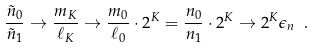<formula> <loc_0><loc_0><loc_500><loc_500>\frac { \tilde { n } _ { 0 } } { \tilde { n } _ { 1 } } \rightarrow \frac { m _ { K } } { \ell _ { K } } \rightarrow \frac { m _ { 0 } } { \ell _ { 0 } } \cdot 2 ^ { K } = \frac { n _ { 0 } } { n _ { 1 } } \cdot 2 ^ { K } \rightarrow 2 ^ { K } \epsilon _ { n } \ .</formula> 